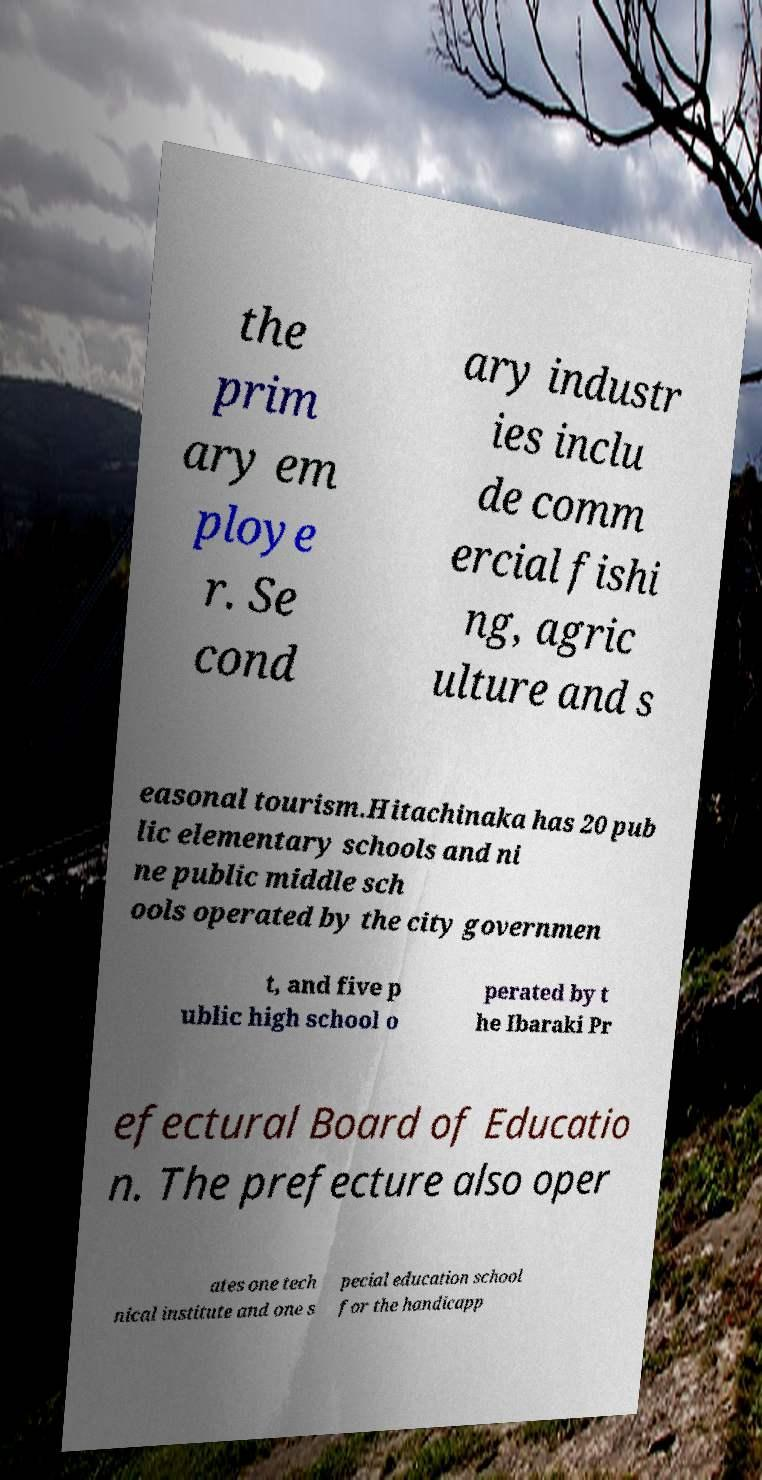Can you accurately transcribe the text from the provided image for me? the prim ary em ploye r. Se cond ary industr ies inclu de comm ercial fishi ng, agric ulture and s easonal tourism.Hitachinaka has 20 pub lic elementary schools and ni ne public middle sch ools operated by the city governmen t, and five p ublic high school o perated by t he Ibaraki Pr efectural Board of Educatio n. The prefecture also oper ates one tech nical institute and one s pecial education school for the handicapp 